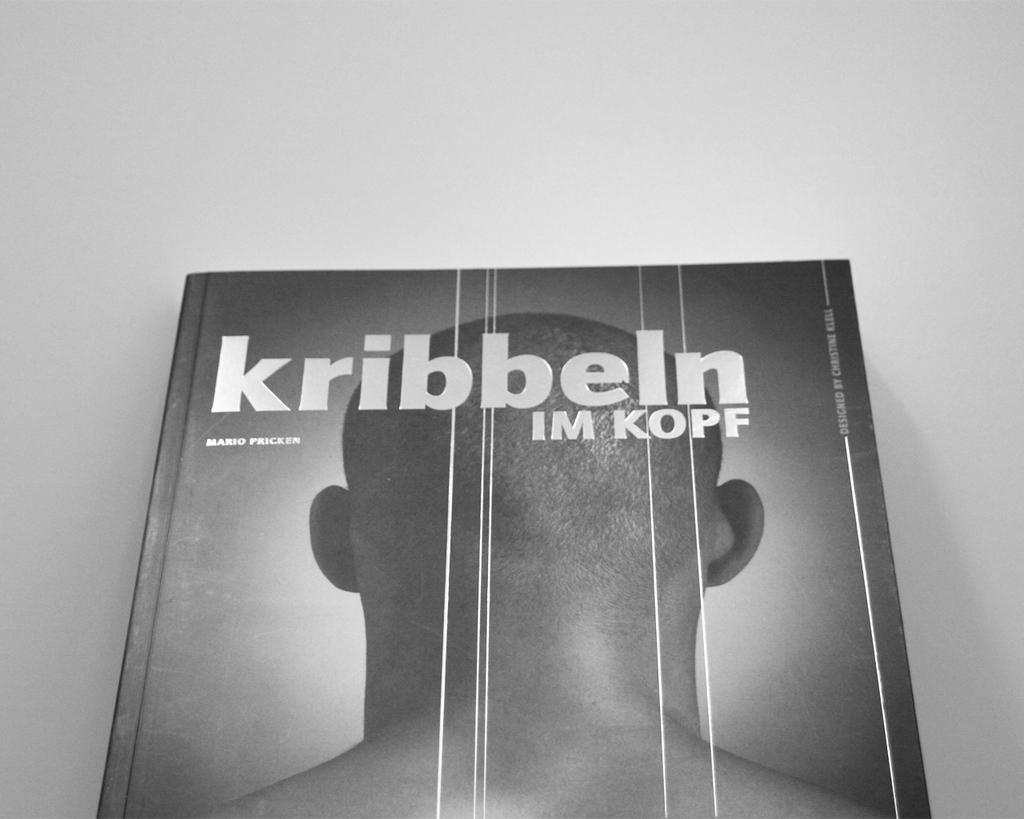Provide a one-sentence caption for the provided image. A book name Kribbeln Im Kopf written by Mario Pricker sits face up. 